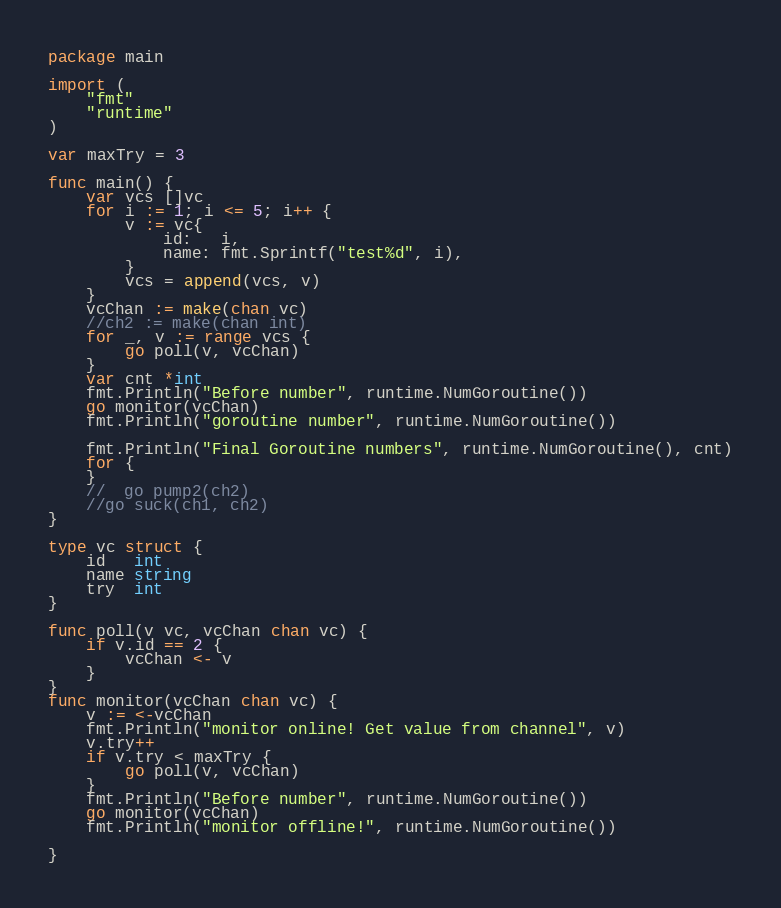<code> <loc_0><loc_0><loc_500><loc_500><_Go_>package main

import (
	"fmt"
	"runtime"
)

var maxTry = 3

func main() {
	var vcs []vc
	for i := 1; i <= 5; i++ {
		v := vc{
			id:   i,
			name: fmt.Sprintf("test%d", i),
		}
		vcs = append(vcs, v)
	}
	vcChan := make(chan vc)
	//ch2 := make(chan int)
	for _, v := range vcs {
		go poll(v, vcChan)
	}
	var cnt *int
	fmt.Println("Before number", runtime.NumGoroutine())
	go monitor(vcChan)
	fmt.Println("goroutine number", runtime.NumGoroutine())

	fmt.Println("Final Goroutine numbers", runtime.NumGoroutine(), cnt)
	for {
	}
	//	go pump2(ch2)
	//go suck(ch1, ch2)
}

type vc struct {
	id   int
	name string
	try  int
}

func poll(v vc, vcChan chan vc) {
	if v.id == 2 {
		vcChan <- v
	}
}
func monitor(vcChan chan vc) {
	v := <-vcChan
	fmt.Println("monitor online! Get value from channel", v)
	v.try++
	if v.try < maxTry {
		go poll(v, vcChan)
	}
	fmt.Println("Before number", runtime.NumGoroutine())
	go monitor(vcChan)
	fmt.Println("monitor offline!", runtime.NumGoroutine())

}
</code> 